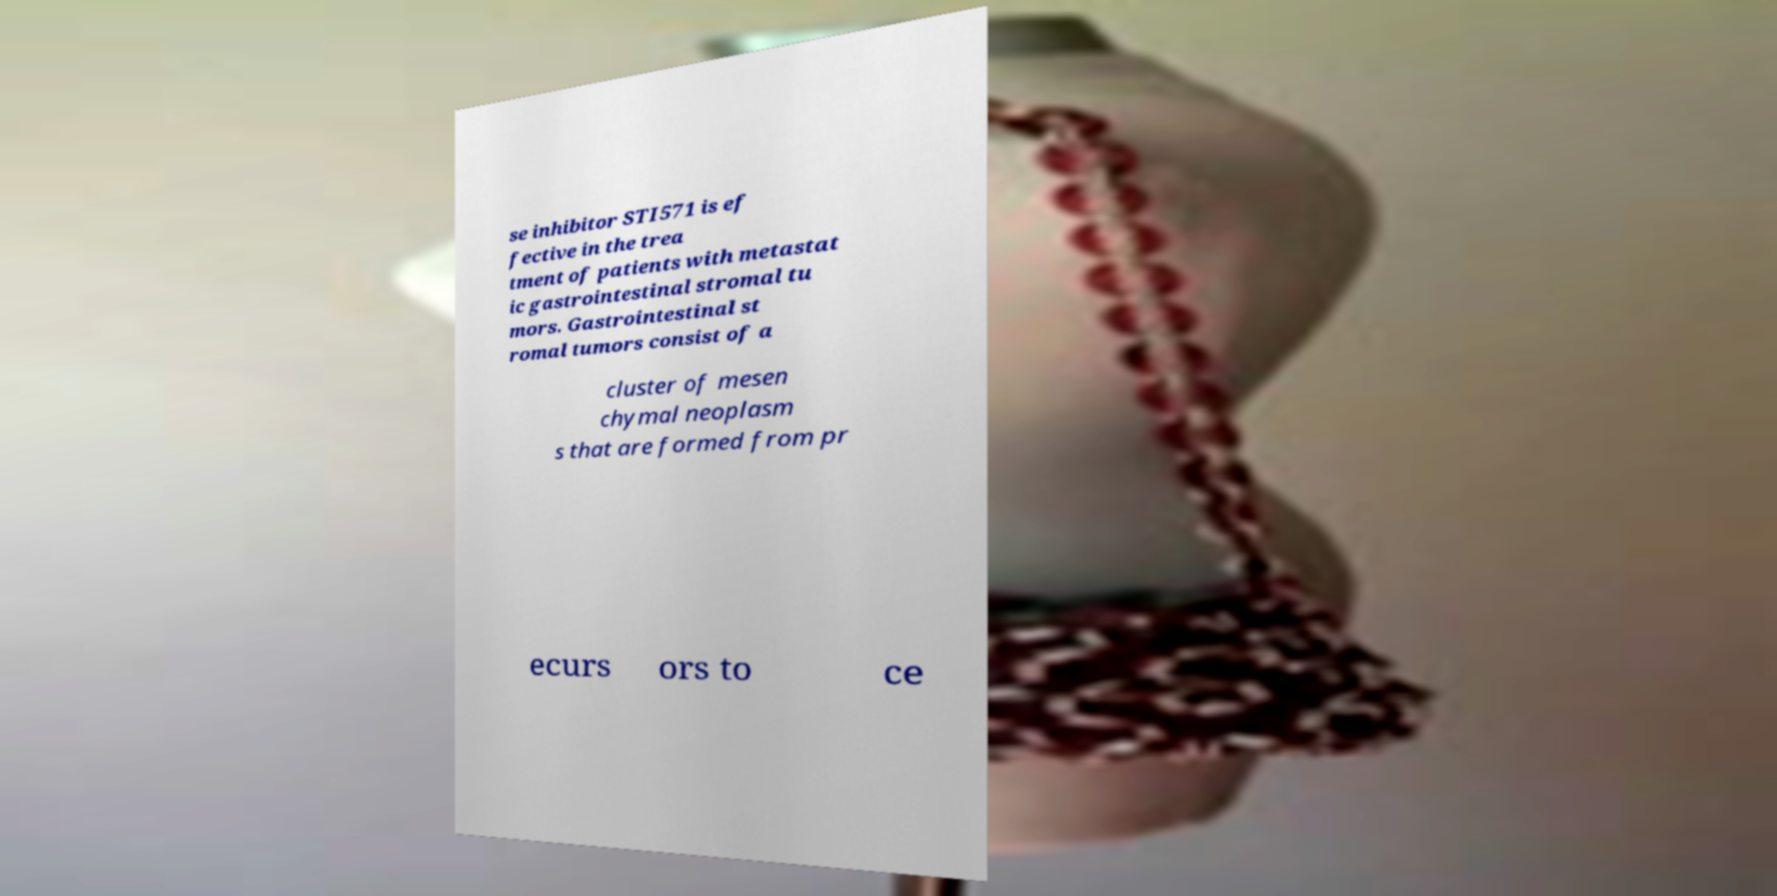Please identify and transcribe the text found in this image. se inhibitor STI571 is ef fective in the trea tment of patients with metastat ic gastrointestinal stromal tu mors. Gastrointestinal st romal tumors consist of a cluster of mesen chymal neoplasm s that are formed from pr ecurs ors to ce 